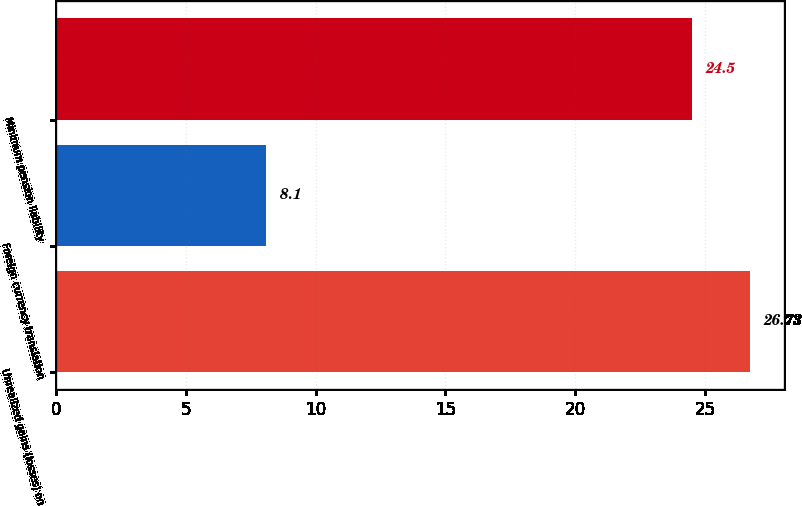Convert chart. <chart><loc_0><loc_0><loc_500><loc_500><bar_chart><fcel>Unrealized gains (losses) on<fcel>Foreign currency translation<fcel>Minimum pension liability<nl><fcel>26.73<fcel>8.1<fcel>24.5<nl></chart> 